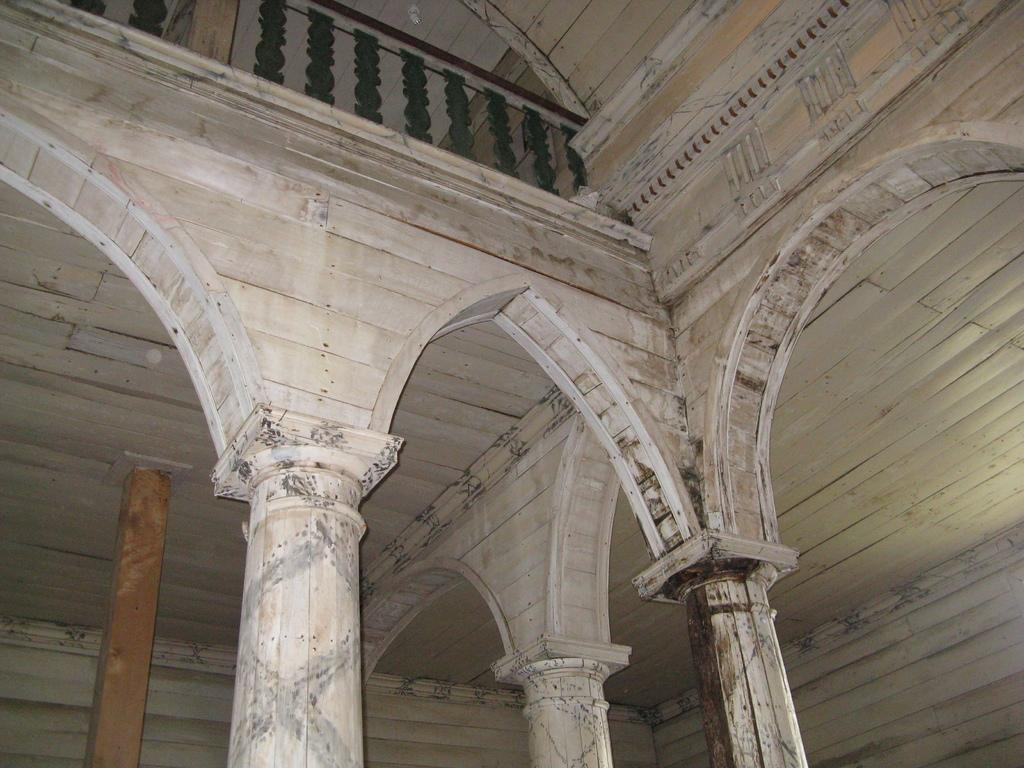What type of location is depicted in the image? The image shows an inside view of a building. What architectural features can be seen in the middle of the picture? There are four pillars in the middle of the picture. What is located at the top of the picture? There is a railing at the top of the picture. What type of toy can be seen floating in the water in the image? There is no water or toy present in the image; it shows an inside view of a building with pillars and a railing. 